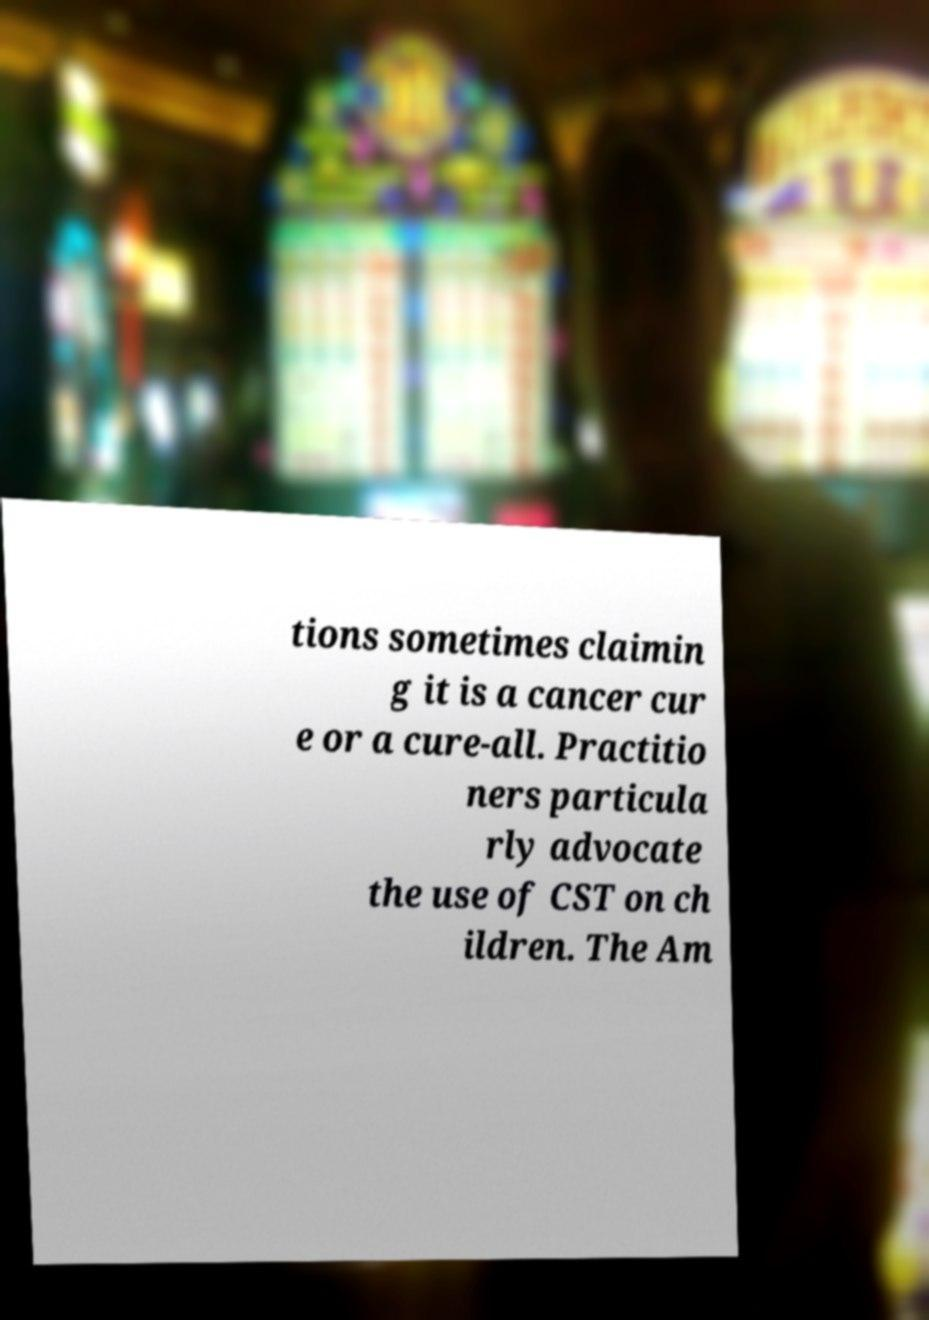Can you accurately transcribe the text from the provided image for me? tions sometimes claimin g it is a cancer cur e or a cure-all. Practitio ners particula rly advocate the use of CST on ch ildren. The Am 